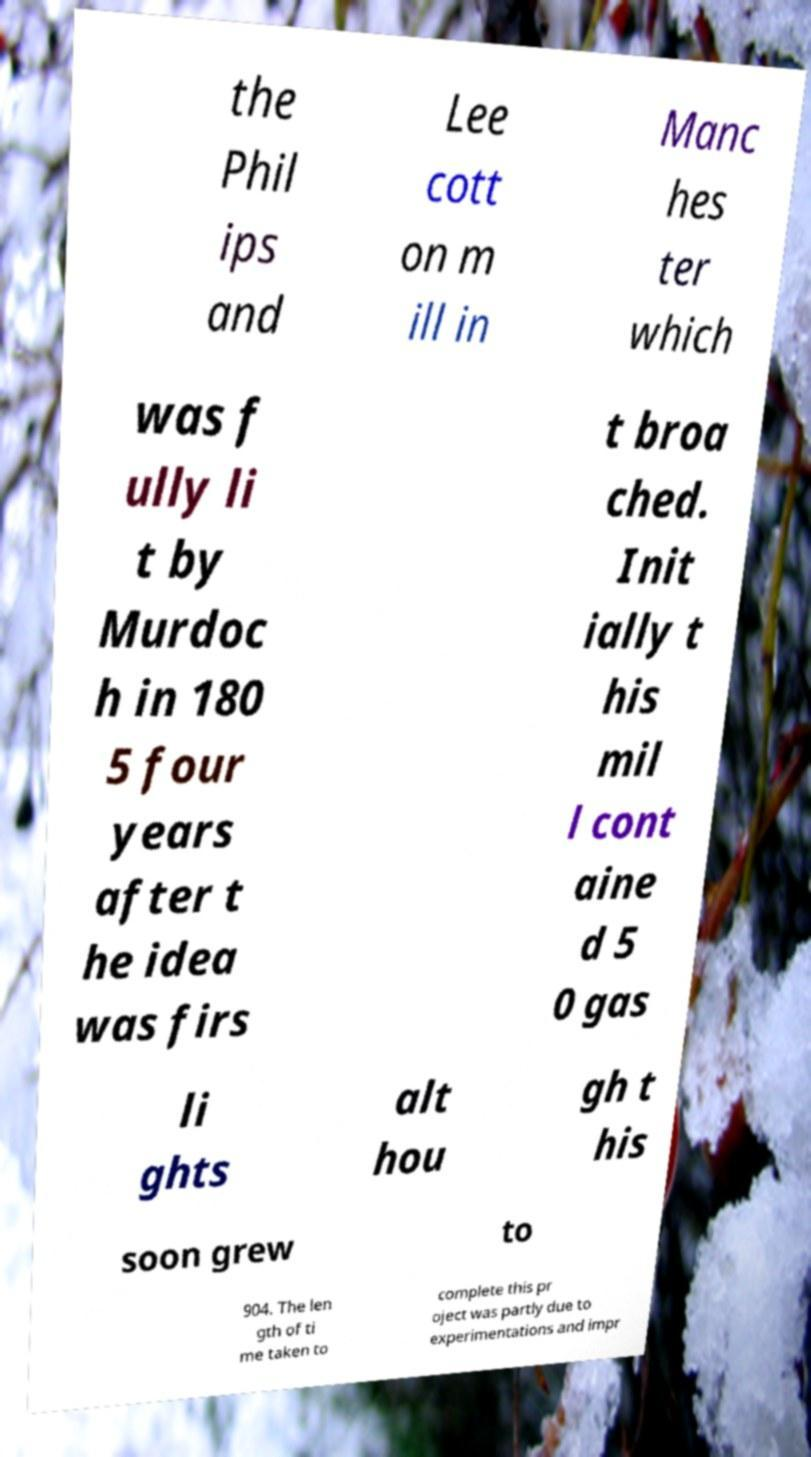What messages or text are displayed in this image? I need them in a readable, typed format. the Phil ips and Lee cott on m ill in Manc hes ter which was f ully li t by Murdoc h in 180 5 four years after t he idea was firs t broa ched. Init ially t his mil l cont aine d 5 0 gas li ghts alt hou gh t his soon grew to 904. The len gth of ti me taken to complete this pr oject was partly due to experimentations and impr 